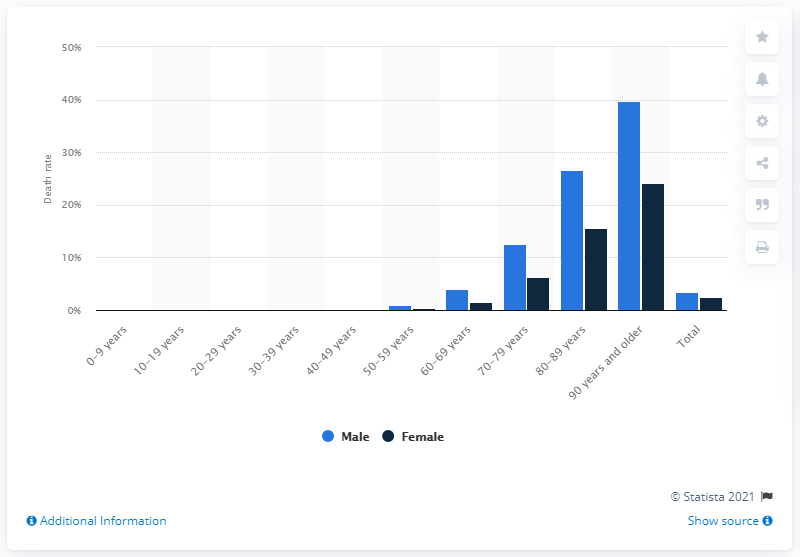Give some essential details in this illustration. The mortality rate for female patients was 2.5%. 